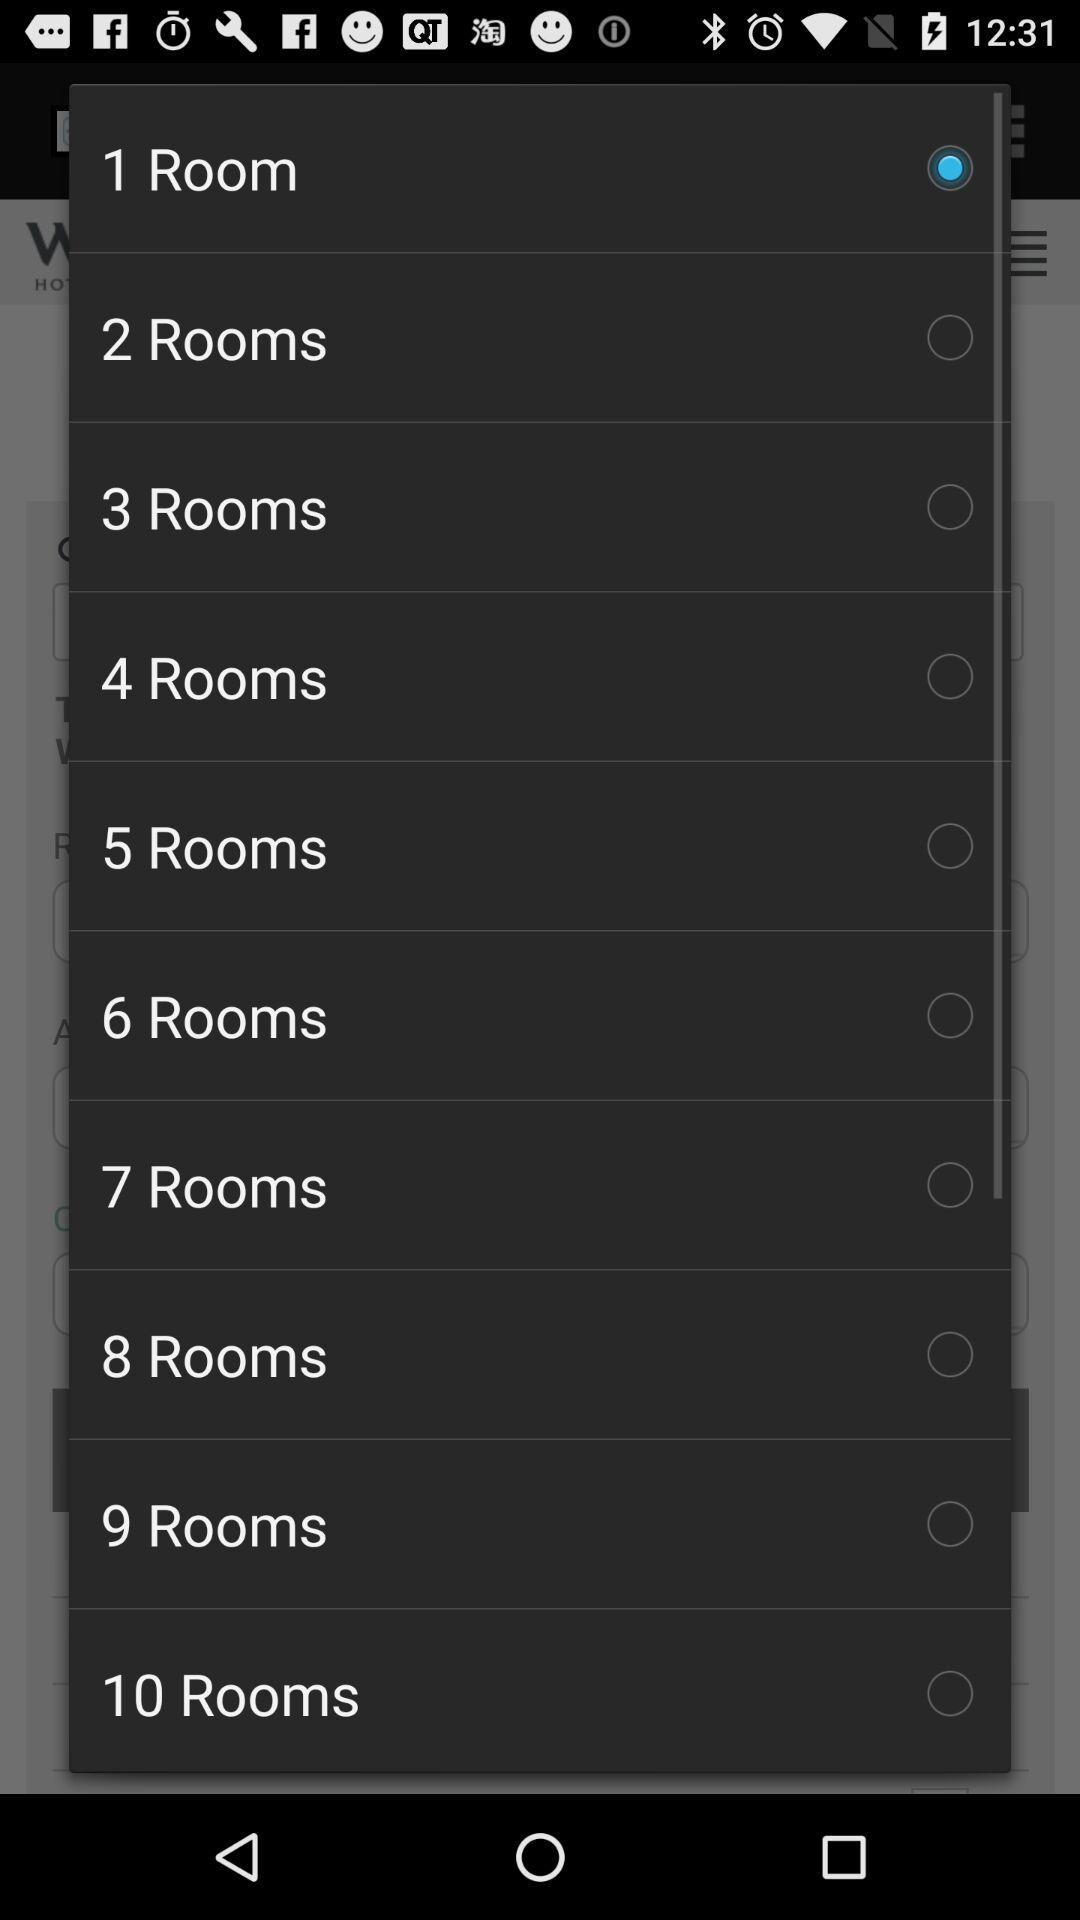How many rooms are there in total?
Answer the question using a single word or phrase. 10 